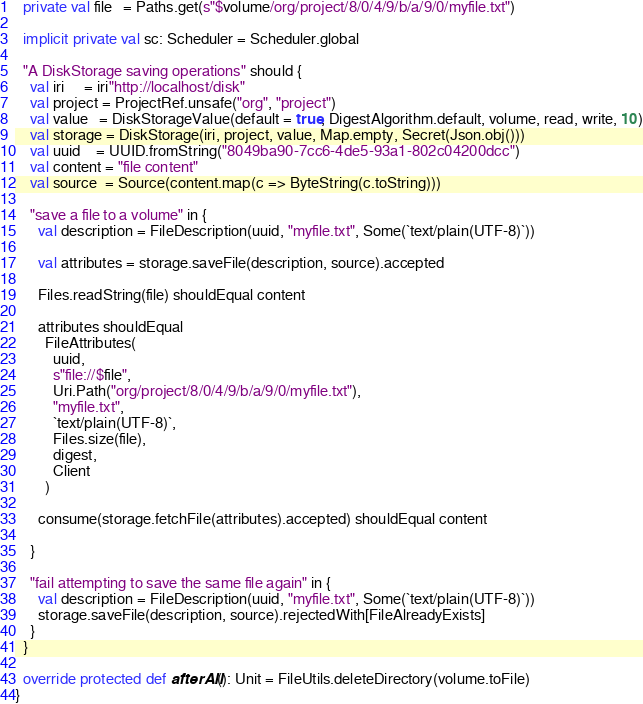<code> <loc_0><loc_0><loc_500><loc_500><_Scala_>  private val file   = Paths.get(s"$volume/org/project/8/0/4/9/b/a/9/0/myfile.txt")

  implicit private val sc: Scheduler = Scheduler.global

  "A DiskStorage saving operations" should {
    val iri     = iri"http://localhost/disk"
    val project = ProjectRef.unsafe("org", "project")
    val value   = DiskStorageValue(default = true, DigestAlgorithm.default, volume, read, write, 10)
    val storage = DiskStorage(iri, project, value, Map.empty, Secret(Json.obj()))
    val uuid    = UUID.fromString("8049ba90-7cc6-4de5-93a1-802c04200dcc")
    val content = "file content"
    val source  = Source(content.map(c => ByteString(c.toString)))

    "save a file to a volume" in {
      val description = FileDescription(uuid, "myfile.txt", Some(`text/plain(UTF-8)`))

      val attributes = storage.saveFile(description, source).accepted

      Files.readString(file) shouldEqual content

      attributes shouldEqual
        FileAttributes(
          uuid,
          s"file://$file",
          Uri.Path("org/project/8/0/4/9/b/a/9/0/myfile.txt"),
          "myfile.txt",
          `text/plain(UTF-8)`,
          Files.size(file),
          digest,
          Client
        )

      consume(storage.fetchFile(attributes).accepted) shouldEqual content

    }

    "fail attempting to save the same file again" in {
      val description = FileDescription(uuid, "myfile.txt", Some(`text/plain(UTF-8)`))
      storage.saveFile(description, source).rejectedWith[FileAlreadyExists]
    }
  }

  override protected def afterAll(): Unit = FileUtils.deleteDirectory(volume.toFile)
}
</code> 